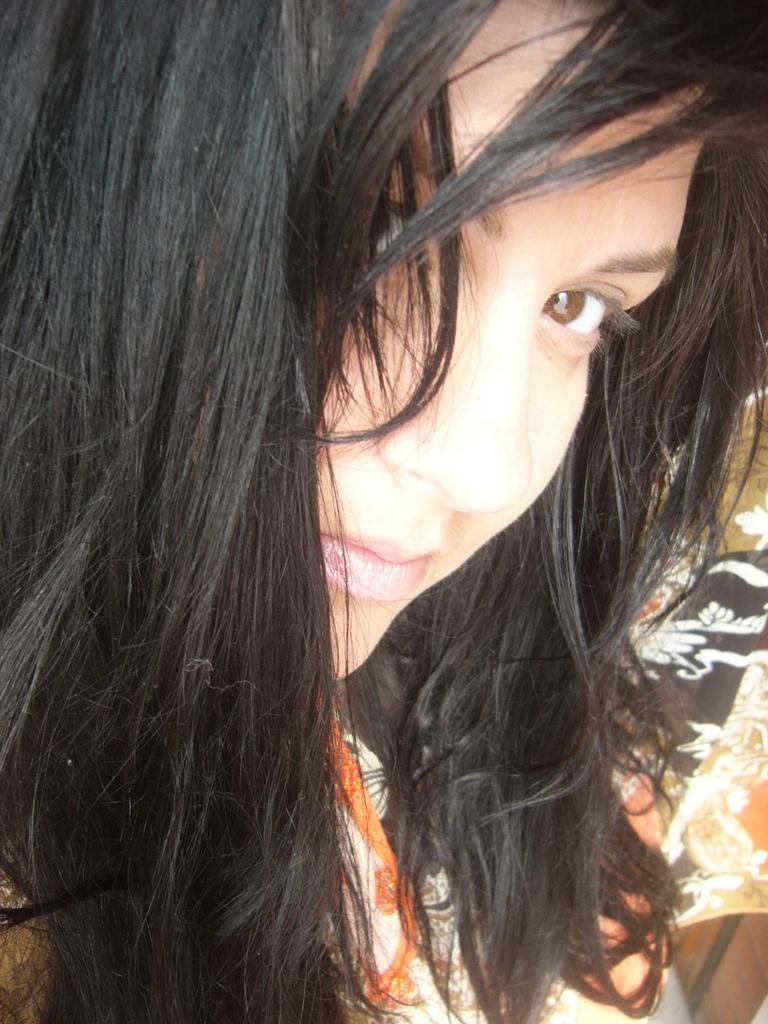Describe this image in one or two sentences. We can see close up image of a girl wearing clothes. 